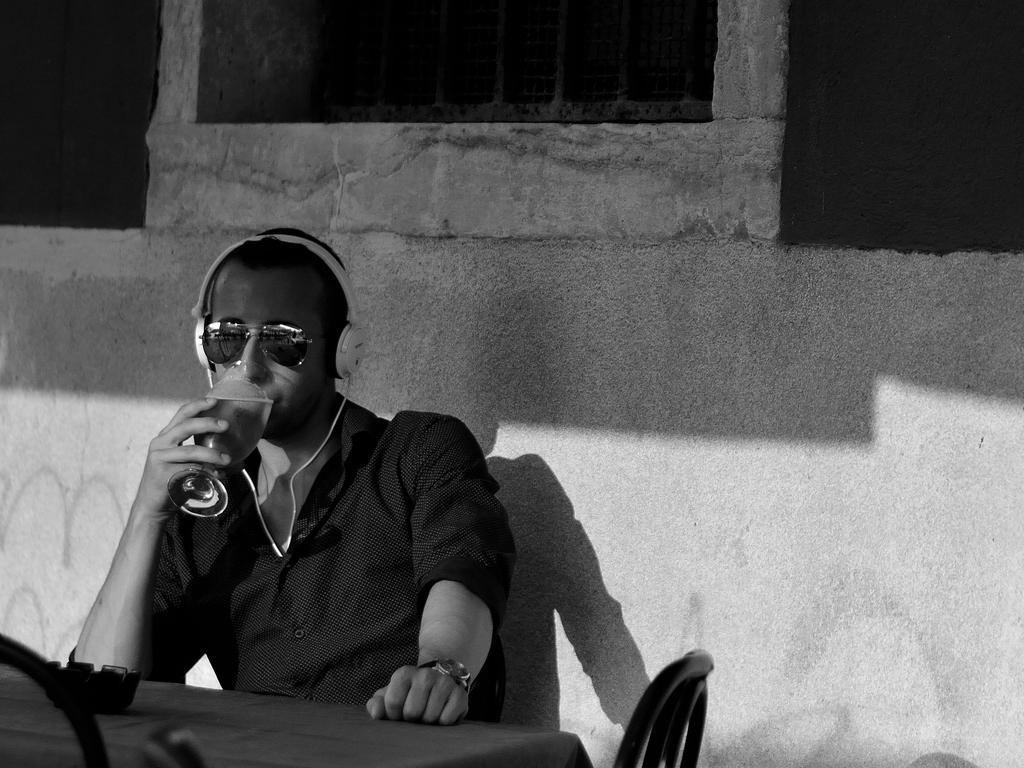Could you give a brief overview of what you see in this image? In this image I see a man who is wearing a shirt and sitting on a chair and is holding a glass and wearing shades and headphones on his ears and I see a table in front of him and I see another chair over here. In the background I see the wall. 